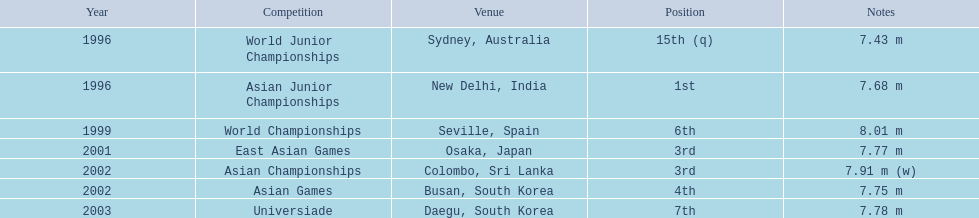What jumps did huang le make in 2002? 7.91 m (w), 7.75 m. Which jump was the longest? 7.91 m (w). 